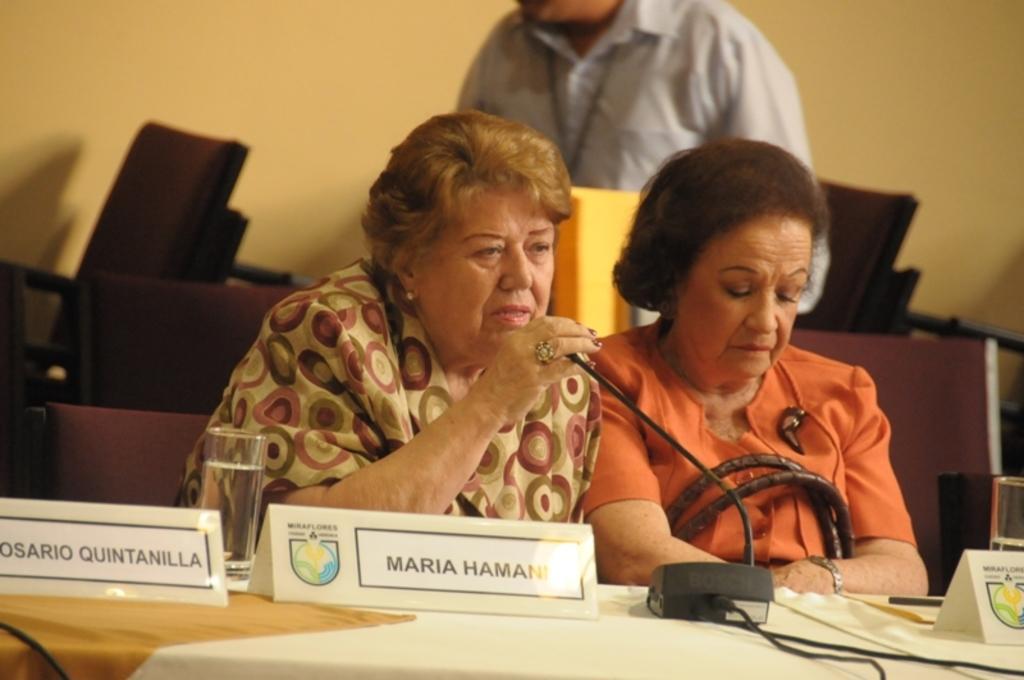Describe this image in one or two sentences. In this image we can see two women sitting. There is a platform. On that there are name boards, mic and glasses. One lady is wearing watch and holding a bag. In the back there is another person. There are chairs. In the background there is a wall. 